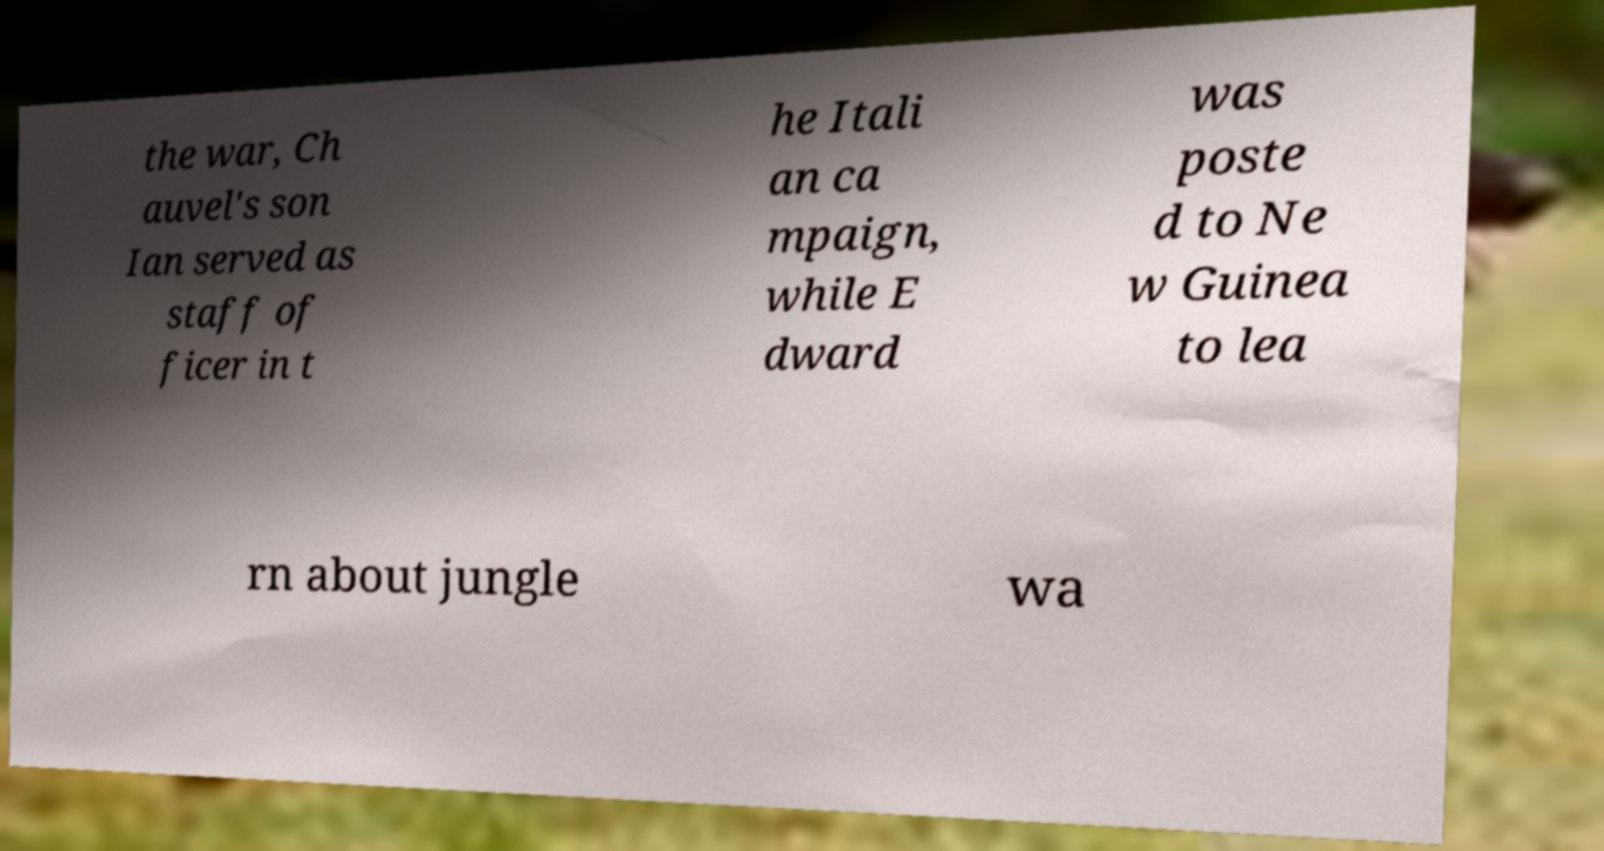Please read and relay the text visible in this image. What does it say? the war, Ch auvel's son Ian served as staff of ficer in t he Itali an ca mpaign, while E dward was poste d to Ne w Guinea to lea rn about jungle wa 